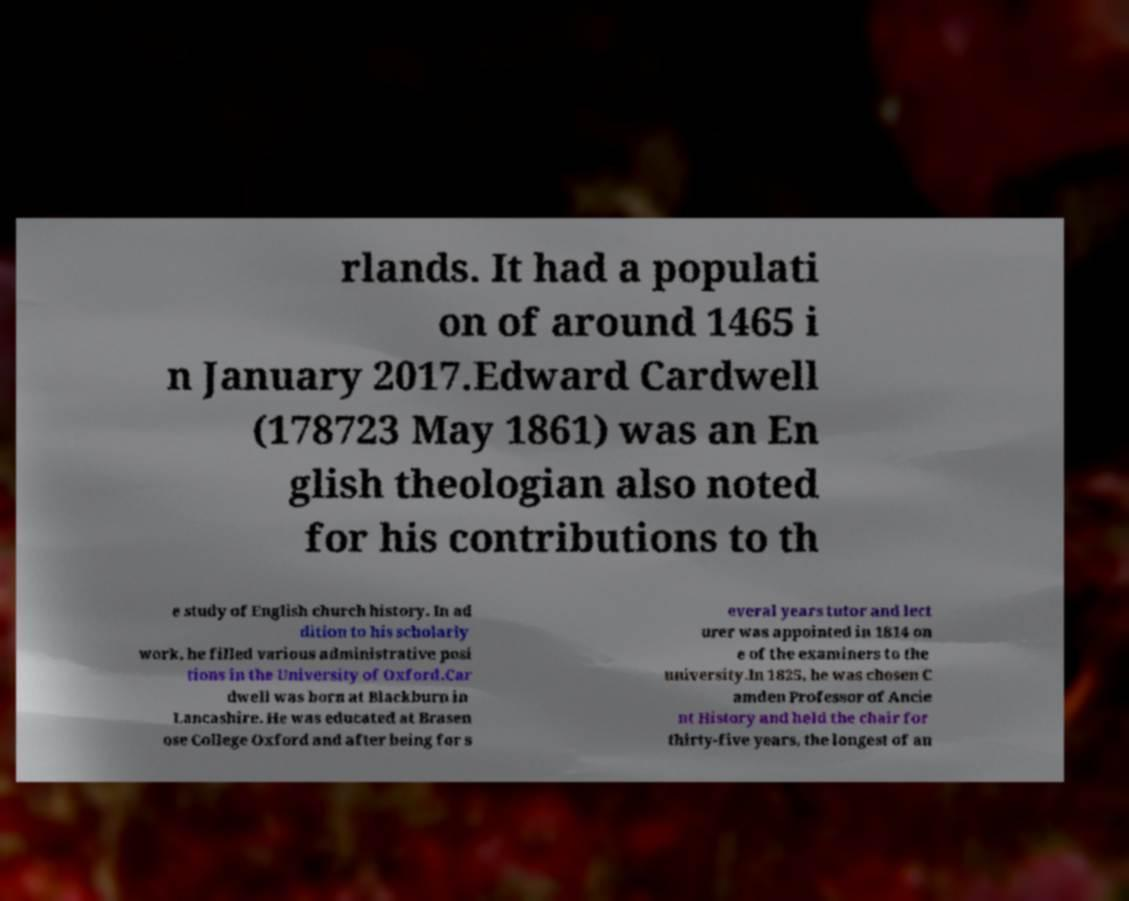Please identify and transcribe the text found in this image. rlands. It had a populati on of around 1465 i n January 2017.Edward Cardwell (178723 May 1861) was an En glish theologian also noted for his contributions to th e study of English church history. In ad dition to his scholarly work, he filled various administrative posi tions in the University of Oxford.Car dwell was born at Blackburn in Lancashire. He was educated at Brasen ose College Oxford and after being for s everal years tutor and lect urer was appointed in 1814 on e of the examiners to the university.In 1825, he was chosen C amden Professor of Ancie nt History and held the chair for thirty-five years, the longest of an 